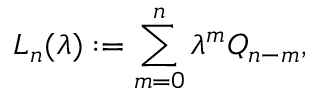Convert formula to latex. <formula><loc_0><loc_0><loc_500><loc_500>L _ { n } ( \lambda ) \colon = \sum _ { m = 0 } ^ { n } \lambda ^ { m } Q _ { n - m } ,</formula> 